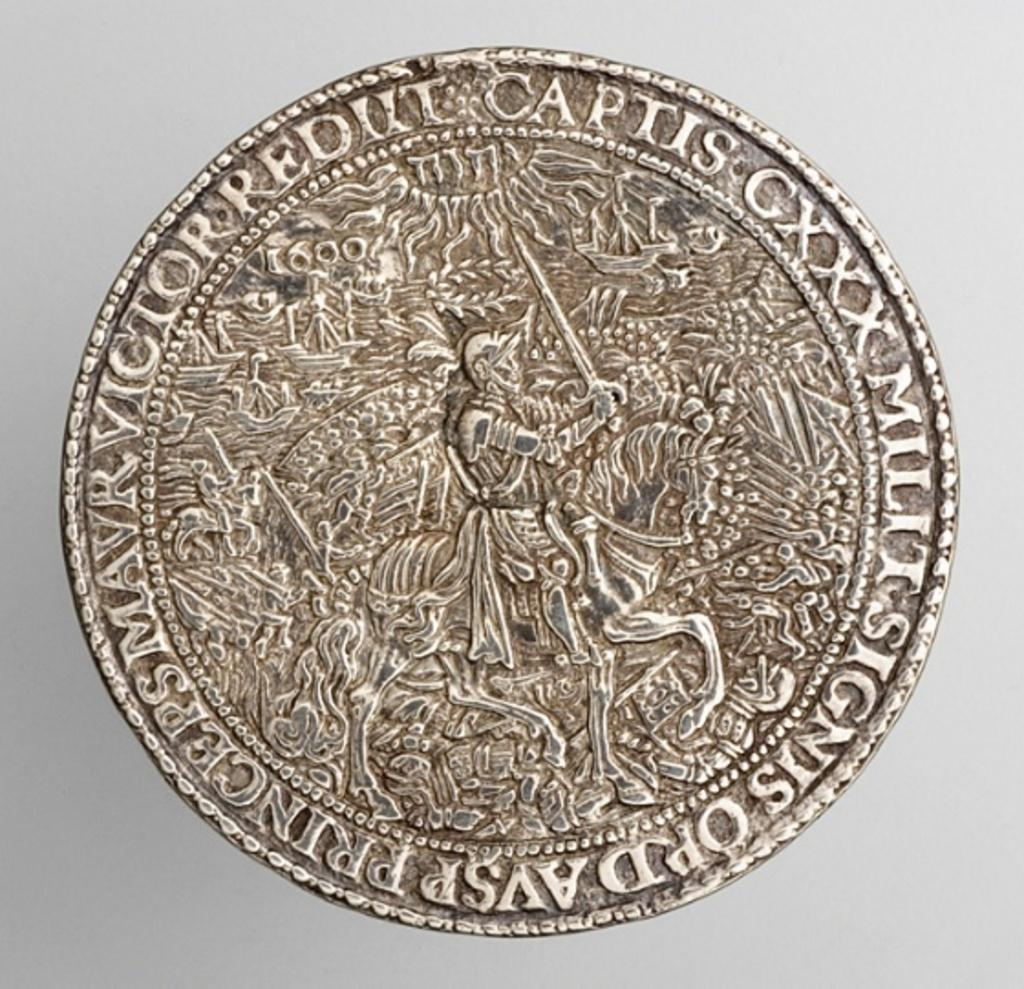<image>
Write a terse but informative summary of the picture. The old collectors coin has lots of detail of a battle. 